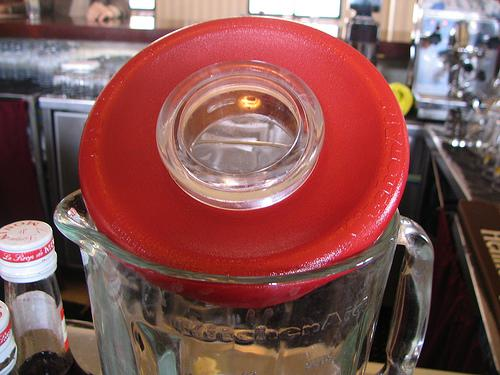Question: what color is the top?
Choices:
A. Red.
B. Blue.
C. Black.
D. Orange.
Answer with the letter. Answer: A Question: how is the photo?
Choices:
A. Black and white.
B. Blurry.
C. Old.
D. Clear.
Answer with the letter. Answer: D Question: who is present?
Choices:
A. Nobody.
B. Everyone.
C. Girl.
D. Guy.
Answer with the letter. Answer: A Question: what else is visible?
Choices:
A. Bottles.
B. Car.
C. House.
D. Man.
Answer with the letter. Answer: A 